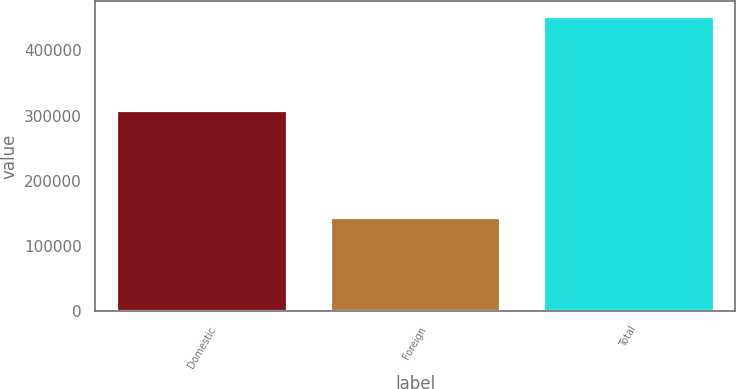Convert chart. <chart><loc_0><loc_0><loc_500><loc_500><bar_chart><fcel>Domestic<fcel>Foreign<fcel>Total<nl><fcel>308238<fcel>144482<fcel>452720<nl></chart> 